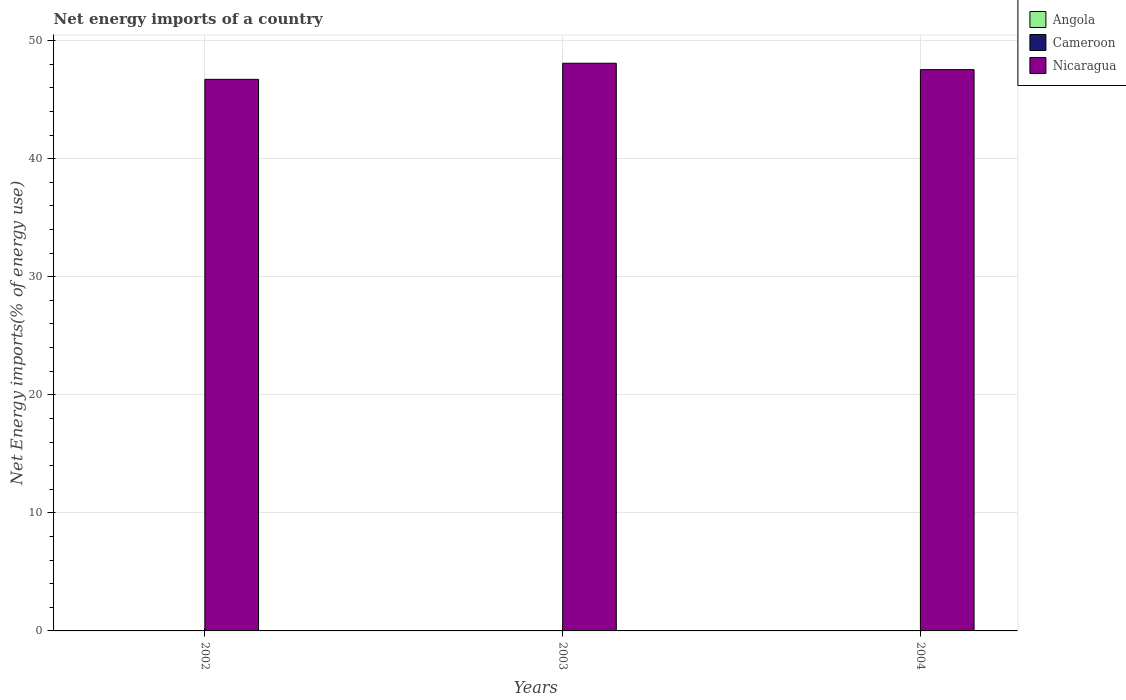How many different coloured bars are there?
Your response must be concise. 1. Are the number of bars per tick equal to the number of legend labels?
Keep it short and to the point. No. How many bars are there on the 3rd tick from the right?
Offer a very short reply. 1. What is the label of the 3rd group of bars from the left?
Your answer should be compact. 2004. What is the net energy imports in Nicaragua in 2002?
Ensure brevity in your answer.  46.72. Across all years, what is the maximum net energy imports in Nicaragua?
Your answer should be very brief. 48.08. Across all years, what is the minimum net energy imports in Nicaragua?
Your answer should be compact. 46.72. In which year was the net energy imports in Nicaragua maximum?
Make the answer very short. 2003. What is the difference between the net energy imports in Nicaragua in 2002 and that in 2003?
Give a very brief answer. -1.36. What is the difference between the net energy imports in Nicaragua in 2003 and the net energy imports in Angola in 2002?
Your response must be concise. 48.08. In how many years, is the net energy imports in Nicaragua greater than 48 %?
Provide a short and direct response. 1. What is the ratio of the net energy imports in Nicaragua in 2002 to that in 2003?
Your answer should be compact. 0.97. What is the difference between the highest and the second highest net energy imports in Nicaragua?
Provide a succinct answer. 0.54. What is the difference between the highest and the lowest net energy imports in Nicaragua?
Give a very brief answer. 1.36. Is the sum of the net energy imports in Nicaragua in 2002 and 2004 greater than the maximum net energy imports in Angola across all years?
Provide a short and direct response. Yes. Is it the case that in every year, the sum of the net energy imports in Nicaragua and net energy imports in Cameroon is greater than the net energy imports in Angola?
Offer a very short reply. Yes. How many years are there in the graph?
Your response must be concise. 3. Does the graph contain any zero values?
Ensure brevity in your answer.  Yes. Does the graph contain grids?
Offer a very short reply. Yes. How are the legend labels stacked?
Give a very brief answer. Vertical. What is the title of the graph?
Offer a terse response. Net energy imports of a country. What is the label or title of the Y-axis?
Provide a succinct answer. Net Energy imports(% of energy use). What is the Net Energy imports(% of energy use) in Angola in 2002?
Provide a short and direct response. 0. What is the Net Energy imports(% of energy use) in Cameroon in 2002?
Ensure brevity in your answer.  0. What is the Net Energy imports(% of energy use) in Nicaragua in 2002?
Offer a very short reply. 46.72. What is the Net Energy imports(% of energy use) of Angola in 2003?
Your response must be concise. 0. What is the Net Energy imports(% of energy use) in Cameroon in 2003?
Your answer should be compact. 0. What is the Net Energy imports(% of energy use) in Nicaragua in 2003?
Offer a very short reply. 48.08. What is the Net Energy imports(% of energy use) in Angola in 2004?
Offer a very short reply. 0. What is the Net Energy imports(% of energy use) of Nicaragua in 2004?
Your answer should be compact. 47.54. Across all years, what is the maximum Net Energy imports(% of energy use) in Nicaragua?
Offer a very short reply. 48.08. Across all years, what is the minimum Net Energy imports(% of energy use) of Nicaragua?
Give a very brief answer. 46.72. What is the total Net Energy imports(% of energy use) of Angola in the graph?
Your response must be concise. 0. What is the total Net Energy imports(% of energy use) of Nicaragua in the graph?
Ensure brevity in your answer.  142.34. What is the difference between the Net Energy imports(% of energy use) in Nicaragua in 2002 and that in 2003?
Your answer should be very brief. -1.36. What is the difference between the Net Energy imports(% of energy use) in Nicaragua in 2002 and that in 2004?
Your response must be concise. -0.82. What is the difference between the Net Energy imports(% of energy use) of Nicaragua in 2003 and that in 2004?
Offer a terse response. 0.54. What is the average Net Energy imports(% of energy use) of Angola per year?
Ensure brevity in your answer.  0. What is the average Net Energy imports(% of energy use) of Nicaragua per year?
Ensure brevity in your answer.  47.45. What is the ratio of the Net Energy imports(% of energy use) of Nicaragua in 2002 to that in 2003?
Offer a terse response. 0.97. What is the ratio of the Net Energy imports(% of energy use) of Nicaragua in 2002 to that in 2004?
Provide a succinct answer. 0.98. What is the ratio of the Net Energy imports(% of energy use) in Nicaragua in 2003 to that in 2004?
Make the answer very short. 1.01. What is the difference between the highest and the second highest Net Energy imports(% of energy use) in Nicaragua?
Your answer should be very brief. 0.54. What is the difference between the highest and the lowest Net Energy imports(% of energy use) in Nicaragua?
Your answer should be compact. 1.36. 